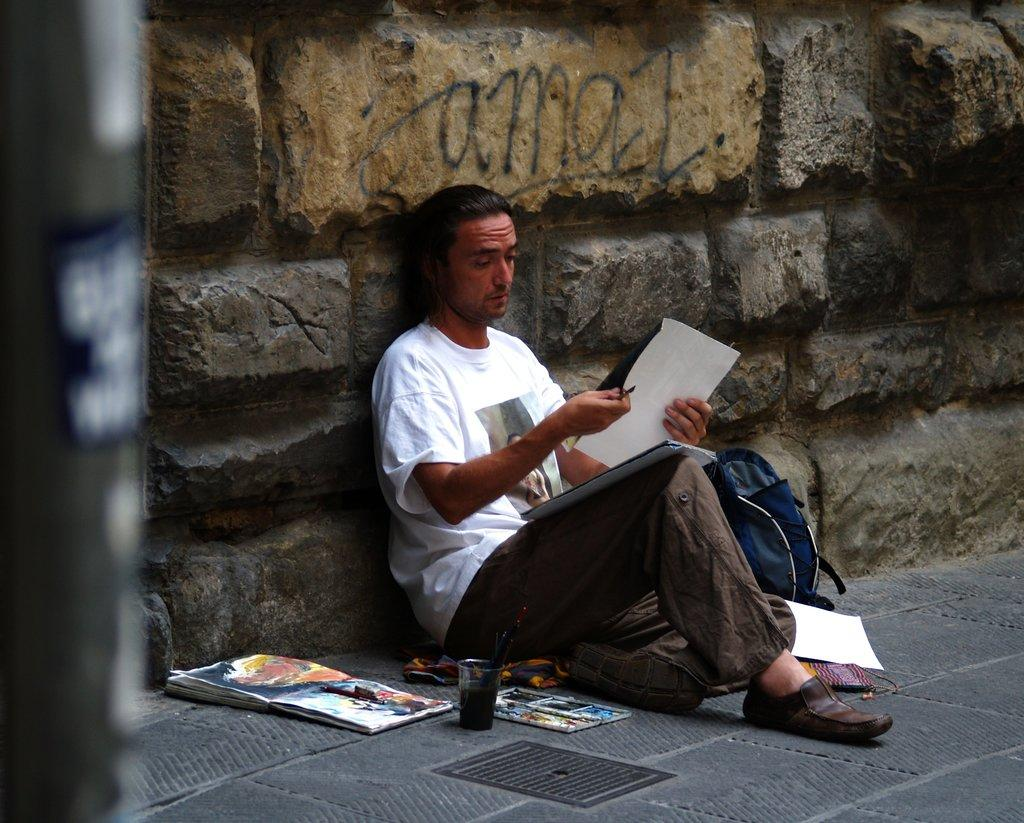What is the person in the image holding? The person is holding a paper. Where is the paper located in relation to the wall? The paper is visible in front of a wall. What other objects can be seen in the image? There is a glass, a book, and a backpack in the image. Are there any additional papers visible in the image? Yes, there are papers on the floor beside the person. What type of lock can be seen on the pig in the image? There is no pig or lock present in the image. Is there a light bulb visible in the image? No, there is no light bulb visible in the image. 